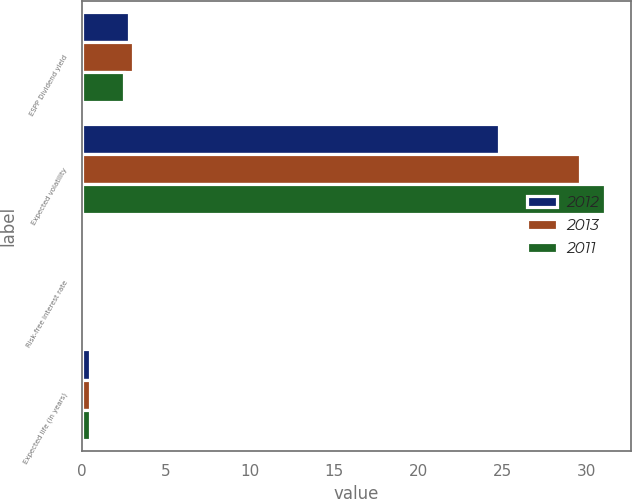Convert chart. <chart><loc_0><loc_0><loc_500><loc_500><stacked_bar_chart><ecel><fcel>ESPP Dividend yield<fcel>Expected volatility<fcel>Risk-free interest rate<fcel>Expected life (in years)<nl><fcel>2012<fcel>2.8<fcel>24.8<fcel>0.09<fcel>0.5<nl><fcel>2013<fcel>3.01<fcel>29.6<fcel>0.13<fcel>0.5<nl><fcel>2011<fcel>2.53<fcel>31.1<fcel>0.09<fcel>0.5<nl></chart> 